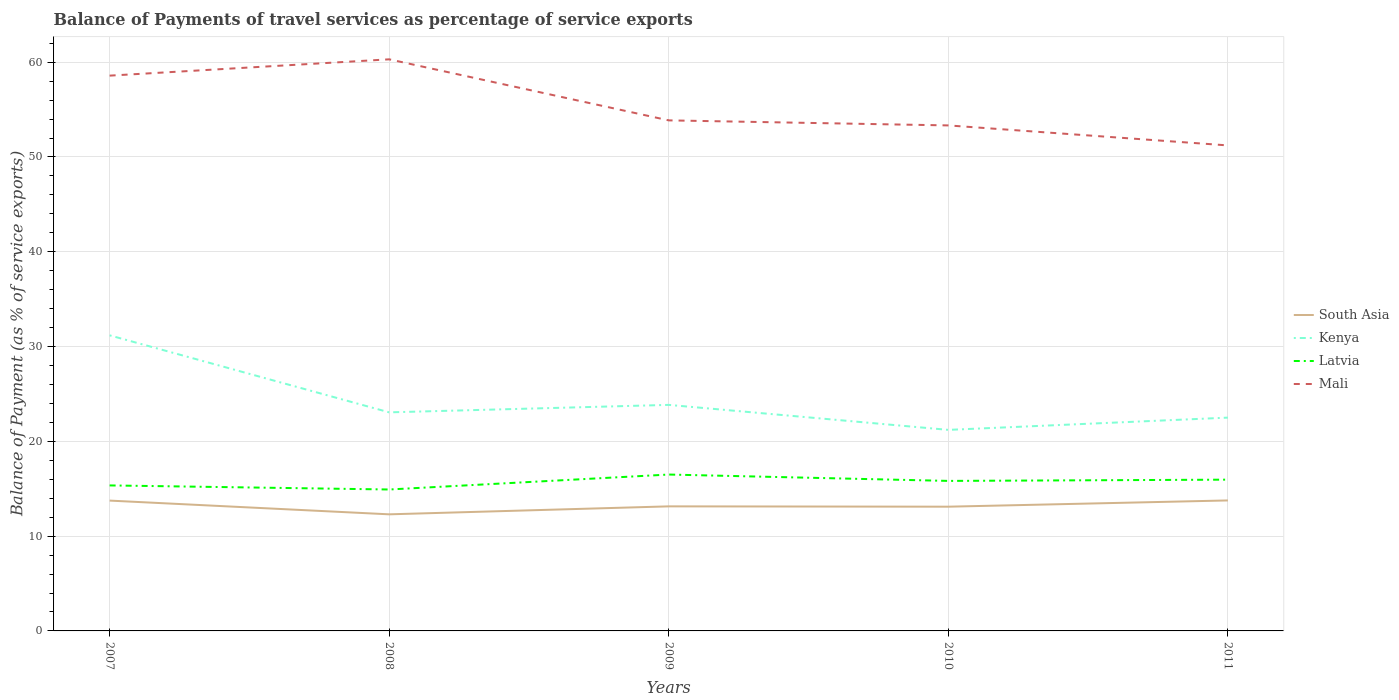Is the number of lines equal to the number of legend labels?
Give a very brief answer. Yes. Across all years, what is the maximum balance of payments of travel services in South Asia?
Give a very brief answer. 12.3. In which year was the balance of payments of travel services in South Asia maximum?
Offer a terse response. 2008. What is the total balance of payments of travel services in Mali in the graph?
Ensure brevity in your answer.  6.97. What is the difference between the highest and the second highest balance of payments of travel services in Kenya?
Ensure brevity in your answer.  9.97. Does the graph contain any zero values?
Your answer should be compact. No. Does the graph contain grids?
Provide a short and direct response. Yes. How are the legend labels stacked?
Offer a terse response. Vertical. What is the title of the graph?
Make the answer very short. Balance of Payments of travel services as percentage of service exports. What is the label or title of the X-axis?
Your response must be concise. Years. What is the label or title of the Y-axis?
Provide a short and direct response. Balance of Payment (as % of service exports). What is the Balance of Payment (as % of service exports) of South Asia in 2007?
Offer a very short reply. 13.75. What is the Balance of Payment (as % of service exports) of Kenya in 2007?
Keep it short and to the point. 31.18. What is the Balance of Payment (as % of service exports) in Latvia in 2007?
Offer a terse response. 15.35. What is the Balance of Payment (as % of service exports) of Mali in 2007?
Offer a very short reply. 58.58. What is the Balance of Payment (as % of service exports) of South Asia in 2008?
Offer a very short reply. 12.3. What is the Balance of Payment (as % of service exports) in Kenya in 2008?
Give a very brief answer. 23.06. What is the Balance of Payment (as % of service exports) in Latvia in 2008?
Keep it short and to the point. 14.92. What is the Balance of Payment (as % of service exports) of Mali in 2008?
Provide a short and direct response. 60.3. What is the Balance of Payment (as % of service exports) of South Asia in 2009?
Offer a very short reply. 13.14. What is the Balance of Payment (as % of service exports) of Kenya in 2009?
Ensure brevity in your answer.  23.85. What is the Balance of Payment (as % of service exports) in Latvia in 2009?
Provide a succinct answer. 16.5. What is the Balance of Payment (as % of service exports) of Mali in 2009?
Provide a short and direct response. 53.86. What is the Balance of Payment (as % of service exports) in South Asia in 2010?
Make the answer very short. 13.11. What is the Balance of Payment (as % of service exports) of Kenya in 2010?
Keep it short and to the point. 21.21. What is the Balance of Payment (as % of service exports) in Latvia in 2010?
Keep it short and to the point. 15.83. What is the Balance of Payment (as % of service exports) in Mali in 2010?
Your answer should be compact. 53.33. What is the Balance of Payment (as % of service exports) of South Asia in 2011?
Offer a terse response. 13.77. What is the Balance of Payment (as % of service exports) in Kenya in 2011?
Your answer should be compact. 22.5. What is the Balance of Payment (as % of service exports) of Latvia in 2011?
Provide a succinct answer. 15.96. What is the Balance of Payment (as % of service exports) in Mali in 2011?
Ensure brevity in your answer.  51.22. Across all years, what is the maximum Balance of Payment (as % of service exports) in South Asia?
Give a very brief answer. 13.77. Across all years, what is the maximum Balance of Payment (as % of service exports) of Kenya?
Give a very brief answer. 31.18. Across all years, what is the maximum Balance of Payment (as % of service exports) of Latvia?
Provide a short and direct response. 16.5. Across all years, what is the maximum Balance of Payment (as % of service exports) of Mali?
Provide a short and direct response. 60.3. Across all years, what is the minimum Balance of Payment (as % of service exports) of South Asia?
Make the answer very short. 12.3. Across all years, what is the minimum Balance of Payment (as % of service exports) of Kenya?
Ensure brevity in your answer.  21.21. Across all years, what is the minimum Balance of Payment (as % of service exports) in Latvia?
Your answer should be very brief. 14.92. Across all years, what is the minimum Balance of Payment (as % of service exports) in Mali?
Offer a terse response. 51.22. What is the total Balance of Payment (as % of service exports) in South Asia in the graph?
Your response must be concise. 66.07. What is the total Balance of Payment (as % of service exports) of Kenya in the graph?
Make the answer very short. 121.8. What is the total Balance of Payment (as % of service exports) of Latvia in the graph?
Make the answer very short. 78.55. What is the total Balance of Payment (as % of service exports) in Mali in the graph?
Keep it short and to the point. 277.3. What is the difference between the Balance of Payment (as % of service exports) of South Asia in 2007 and that in 2008?
Your answer should be very brief. 1.45. What is the difference between the Balance of Payment (as % of service exports) in Kenya in 2007 and that in 2008?
Your answer should be very brief. 8.12. What is the difference between the Balance of Payment (as % of service exports) in Latvia in 2007 and that in 2008?
Give a very brief answer. 0.43. What is the difference between the Balance of Payment (as % of service exports) of Mali in 2007 and that in 2008?
Provide a succinct answer. -1.72. What is the difference between the Balance of Payment (as % of service exports) in South Asia in 2007 and that in 2009?
Offer a very short reply. 0.61. What is the difference between the Balance of Payment (as % of service exports) in Kenya in 2007 and that in 2009?
Your answer should be compact. 7.34. What is the difference between the Balance of Payment (as % of service exports) in Latvia in 2007 and that in 2009?
Provide a short and direct response. -1.15. What is the difference between the Balance of Payment (as % of service exports) in Mali in 2007 and that in 2009?
Offer a very short reply. 4.72. What is the difference between the Balance of Payment (as % of service exports) in South Asia in 2007 and that in 2010?
Make the answer very short. 0.64. What is the difference between the Balance of Payment (as % of service exports) of Kenya in 2007 and that in 2010?
Your response must be concise. 9.97. What is the difference between the Balance of Payment (as % of service exports) of Latvia in 2007 and that in 2010?
Your answer should be compact. -0.48. What is the difference between the Balance of Payment (as % of service exports) of Mali in 2007 and that in 2010?
Your answer should be very brief. 5.25. What is the difference between the Balance of Payment (as % of service exports) of South Asia in 2007 and that in 2011?
Ensure brevity in your answer.  -0.02. What is the difference between the Balance of Payment (as % of service exports) of Kenya in 2007 and that in 2011?
Your response must be concise. 8.68. What is the difference between the Balance of Payment (as % of service exports) of Latvia in 2007 and that in 2011?
Your answer should be very brief. -0.61. What is the difference between the Balance of Payment (as % of service exports) of Mali in 2007 and that in 2011?
Your response must be concise. 7.36. What is the difference between the Balance of Payment (as % of service exports) of South Asia in 2008 and that in 2009?
Offer a very short reply. -0.84. What is the difference between the Balance of Payment (as % of service exports) in Kenya in 2008 and that in 2009?
Ensure brevity in your answer.  -0.79. What is the difference between the Balance of Payment (as % of service exports) of Latvia in 2008 and that in 2009?
Ensure brevity in your answer.  -1.58. What is the difference between the Balance of Payment (as % of service exports) of Mali in 2008 and that in 2009?
Make the answer very short. 6.44. What is the difference between the Balance of Payment (as % of service exports) of South Asia in 2008 and that in 2010?
Make the answer very short. -0.81. What is the difference between the Balance of Payment (as % of service exports) in Kenya in 2008 and that in 2010?
Provide a succinct answer. 1.85. What is the difference between the Balance of Payment (as % of service exports) in Latvia in 2008 and that in 2010?
Keep it short and to the point. -0.91. What is the difference between the Balance of Payment (as % of service exports) of Mali in 2008 and that in 2010?
Your response must be concise. 6.97. What is the difference between the Balance of Payment (as % of service exports) in South Asia in 2008 and that in 2011?
Provide a succinct answer. -1.47. What is the difference between the Balance of Payment (as % of service exports) of Kenya in 2008 and that in 2011?
Keep it short and to the point. 0.56. What is the difference between the Balance of Payment (as % of service exports) of Latvia in 2008 and that in 2011?
Your response must be concise. -1.04. What is the difference between the Balance of Payment (as % of service exports) of Mali in 2008 and that in 2011?
Offer a very short reply. 9.08. What is the difference between the Balance of Payment (as % of service exports) in South Asia in 2009 and that in 2010?
Give a very brief answer. 0.04. What is the difference between the Balance of Payment (as % of service exports) in Kenya in 2009 and that in 2010?
Give a very brief answer. 2.64. What is the difference between the Balance of Payment (as % of service exports) of Latvia in 2009 and that in 2010?
Your answer should be very brief. 0.67. What is the difference between the Balance of Payment (as % of service exports) in Mali in 2009 and that in 2010?
Your response must be concise. 0.53. What is the difference between the Balance of Payment (as % of service exports) in South Asia in 2009 and that in 2011?
Your answer should be compact. -0.62. What is the difference between the Balance of Payment (as % of service exports) in Kenya in 2009 and that in 2011?
Provide a short and direct response. 1.34. What is the difference between the Balance of Payment (as % of service exports) in Latvia in 2009 and that in 2011?
Provide a short and direct response. 0.54. What is the difference between the Balance of Payment (as % of service exports) in Mali in 2009 and that in 2011?
Keep it short and to the point. 2.64. What is the difference between the Balance of Payment (as % of service exports) of South Asia in 2010 and that in 2011?
Your response must be concise. -0.66. What is the difference between the Balance of Payment (as % of service exports) in Kenya in 2010 and that in 2011?
Provide a short and direct response. -1.29. What is the difference between the Balance of Payment (as % of service exports) of Latvia in 2010 and that in 2011?
Offer a very short reply. -0.13. What is the difference between the Balance of Payment (as % of service exports) in Mali in 2010 and that in 2011?
Provide a short and direct response. 2.11. What is the difference between the Balance of Payment (as % of service exports) in South Asia in 2007 and the Balance of Payment (as % of service exports) in Kenya in 2008?
Give a very brief answer. -9.31. What is the difference between the Balance of Payment (as % of service exports) of South Asia in 2007 and the Balance of Payment (as % of service exports) of Latvia in 2008?
Your answer should be compact. -1.17. What is the difference between the Balance of Payment (as % of service exports) of South Asia in 2007 and the Balance of Payment (as % of service exports) of Mali in 2008?
Provide a succinct answer. -46.55. What is the difference between the Balance of Payment (as % of service exports) of Kenya in 2007 and the Balance of Payment (as % of service exports) of Latvia in 2008?
Offer a very short reply. 16.26. What is the difference between the Balance of Payment (as % of service exports) in Kenya in 2007 and the Balance of Payment (as % of service exports) in Mali in 2008?
Provide a short and direct response. -29.12. What is the difference between the Balance of Payment (as % of service exports) in Latvia in 2007 and the Balance of Payment (as % of service exports) in Mali in 2008?
Your response must be concise. -44.95. What is the difference between the Balance of Payment (as % of service exports) in South Asia in 2007 and the Balance of Payment (as % of service exports) in Kenya in 2009?
Your response must be concise. -10.1. What is the difference between the Balance of Payment (as % of service exports) in South Asia in 2007 and the Balance of Payment (as % of service exports) in Latvia in 2009?
Provide a succinct answer. -2.75. What is the difference between the Balance of Payment (as % of service exports) of South Asia in 2007 and the Balance of Payment (as % of service exports) of Mali in 2009?
Offer a terse response. -40.11. What is the difference between the Balance of Payment (as % of service exports) in Kenya in 2007 and the Balance of Payment (as % of service exports) in Latvia in 2009?
Give a very brief answer. 14.69. What is the difference between the Balance of Payment (as % of service exports) of Kenya in 2007 and the Balance of Payment (as % of service exports) of Mali in 2009?
Provide a succinct answer. -22.68. What is the difference between the Balance of Payment (as % of service exports) in Latvia in 2007 and the Balance of Payment (as % of service exports) in Mali in 2009?
Give a very brief answer. -38.51. What is the difference between the Balance of Payment (as % of service exports) in South Asia in 2007 and the Balance of Payment (as % of service exports) in Kenya in 2010?
Your answer should be very brief. -7.46. What is the difference between the Balance of Payment (as % of service exports) of South Asia in 2007 and the Balance of Payment (as % of service exports) of Latvia in 2010?
Ensure brevity in your answer.  -2.08. What is the difference between the Balance of Payment (as % of service exports) of South Asia in 2007 and the Balance of Payment (as % of service exports) of Mali in 2010?
Give a very brief answer. -39.58. What is the difference between the Balance of Payment (as % of service exports) of Kenya in 2007 and the Balance of Payment (as % of service exports) of Latvia in 2010?
Your answer should be very brief. 15.36. What is the difference between the Balance of Payment (as % of service exports) in Kenya in 2007 and the Balance of Payment (as % of service exports) in Mali in 2010?
Keep it short and to the point. -22.15. What is the difference between the Balance of Payment (as % of service exports) of Latvia in 2007 and the Balance of Payment (as % of service exports) of Mali in 2010?
Give a very brief answer. -37.98. What is the difference between the Balance of Payment (as % of service exports) of South Asia in 2007 and the Balance of Payment (as % of service exports) of Kenya in 2011?
Make the answer very short. -8.75. What is the difference between the Balance of Payment (as % of service exports) in South Asia in 2007 and the Balance of Payment (as % of service exports) in Latvia in 2011?
Offer a terse response. -2.21. What is the difference between the Balance of Payment (as % of service exports) of South Asia in 2007 and the Balance of Payment (as % of service exports) of Mali in 2011?
Give a very brief answer. -37.47. What is the difference between the Balance of Payment (as % of service exports) of Kenya in 2007 and the Balance of Payment (as % of service exports) of Latvia in 2011?
Make the answer very short. 15.23. What is the difference between the Balance of Payment (as % of service exports) of Kenya in 2007 and the Balance of Payment (as % of service exports) of Mali in 2011?
Offer a very short reply. -20.04. What is the difference between the Balance of Payment (as % of service exports) of Latvia in 2007 and the Balance of Payment (as % of service exports) of Mali in 2011?
Your response must be concise. -35.87. What is the difference between the Balance of Payment (as % of service exports) in South Asia in 2008 and the Balance of Payment (as % of service exports) in Kenya in 2009?
Provide a short and direct response. -11.55. What is the difference between the Balance of Payment (as % of service exports) of South Asia in 2008 and the Balance of Payment (as % of service exports) of Latvia in 2009?
Provide a succinct answer. -4.2. What is the difference between the Balance of Payment (as % of service exports) in South Asia in 2008 and the Balance of Payment (as % of service exports) in Mali in 2009?
Keep it short and to the point. -41.56. What is the difference between the Balance of Payment (as % of service exports) in Kenya in 2008 and the Balance of Payment (as % of service exports) in Latvia in 2009?
Offer a very short reply. 6.56. What is the difference between the Balance of Payment (as % of service exports) in Kenya in 2008 and the Balance of Payment (as % of service exports) in Mali in 2009?
Provide a succinct answer. -30.8. What is the difference between the Balance of Payment (as % of service exports) in Latvia in 2008 and the Balance of Payment (as % of service exports) in Mali in 2009?
Your answer should be very brief. -38.94. What is the difference between the Balance of Payment (as % of service exports) of South Asia in 2008 and the Balance of Payment (as % of service exports) of Kenya in 2010?
Your response must be concise. -8.91. What is the difference between the Balance of Payment (as % of service exports) in South Asia in 2008 and the Balance of Payment (as % of service exports) in Latvia in 2010?
Your answer should be very brief. -3.53. What is the difference between the Balance of Payment (as % of service exports) in South Asia in 2008 and the Balance of Payment (as % of service exports) in Mali in 2010?
Give a very brief answer. -41.03. What is the difference between the Balance of Payment (as % of service exports) of Kenya in 2008 and the Balance of Payment (as % of service exports) of Latvia in 2010?
Your answer should be compact. 7.23. What is the difference between the Balance of Payment (as % of service exports) in Kenya in 2008 and the Balance of Payment (as % of service exports) in Mali in 2010?
Keep it short and to the point. -30.27. What is the difference between the Balance of Payment (as % of service exports) of Latvia in 2008 and the Balance of Payment (as % of service exports) of Mali in 2010?
Ensure brevity in your answer.  -38.41. What is the difference between the Balance of Payment (as % of service exports) in South Asia in 2008 and the Balance of Payment (as % of service exports) in Kenya in 2011?
Keep it short and to the point. -10.2. What is the difference between the Balance of Payment (as % of service exports) of South Asia in 2008 and the Balance of Payment (as % of service exports) of Latvia in 2011?
Provide a short and direct response. -3.66. What is the difference between the Balance of Payment (as % of service exports) of South Asia in 2008 and the Balance of Payment (as % of service exports) of Mali in 2011?
Offer a terse response. -38.92. What is the difference between the Balance of Payment (as % of service exports) in Kenya in 2008 and the Balance of Payment (as % of service exports) in Latvia in 2011?
Make the answer very short. 7.1. What is the difference between the Balance of Payment (as % of service exports) in Kenya in 2008 and the Balance of Payment (as % of service exports) in Mali in 2011?
Offer a very short reply. -28.16. What is the difference between the Balance of Payment (as % of service exports) in Latvia in 2008 and the Balance of Payment (as % of service exports) in Mali in 2011?
Provide a short and direct response. -36.3. What is the difference between the Balance of Payment (as % of service exports) of South Asia in 2009 and the Balance of Payment (as % of service exports) of Kenya in 2010?
Ensure brevity in your answer.  -8.07. What is the difference between the Balance of Payment (as % of service exports) in South Asia in 2009 and the Balance of Payment (as % of service exports) in Latvia in 2010?
Provide a succinct answer. -2.68. What is the difference between the Balance of Payment (as % of service exports) in South Asia in 2009 and the Balance of Payment (as % of service exports) in Mali in 2010?
Give a very brief answer. -40.19. What is the difference between the Balance of Payment (as % of service exports) of Kenya in 2009 and the Balance of Payment (as % of service exports) of Latvia in 2010?
Give a very brief answer. 8.02. What is the difference between the Balance of Payment (as % of service exports) of Kenya in 2009 and the Balance of Payment (as % of service exports) of Mali in 2010?
Give a very brief answer. -29.48. What is the difference between the Balance of Payment (as % of service exports) of Latvia in 2009 and the Balance of Payment (as % of service exports) of Mali in 2010?
Your response must be concise. -36.83. What is the difference between the Balance of Payment (as % of service exports) in South Asia in 2009 and the Balance of Payment (as % of service exports) in Kenya in 2011?
Your response must be concise. -9.36. What is the difference between the Balance of Payment (as % of service exports) in South Asia in 2009 and the Balance of Payment (as % of service exports) in Latvia in 2011?
Your response must be concise. -2.82. What is the difference between the Balance of Payment (as % of service exports) in South Asia in 2009 and the Balance of Payment (as % of service exports) in Mali in 2011?
Your response must be concise. -38.08. What is the difference between the Balance of Payment (as % of service exports) in Kenya in 2009 and the Balance of Payment (as % of service exports) in Latvia in 2011?
Your answer should be compact. 7.89. What is the difference between the Balance of Payment (as % of service exports) of Kenya in 2009 and the Balance of Payment (as % of service exports) of Mali in 2011?
Give a very brief answer. -27.37. What is the difference between the Balance of Payment (as % of service exports) of Latvia in 2009 and the Balance of Payment (as % of service exports) of Mali in 2011?
Provide a short and direct response. -34.72. What is the difference between the Balance of Payment (as % of service exports) in South Asia in 2010 and the Balance of Payment (as % of service exports) in Kenya in 2011?
Offer a very short reply. -9.4. What is the difference between the Balance of Payment (as % of service exports) of South Asia in 2010 and the Balance of Payment (as % of service exports) of Latvia in 2011?
Provide a succinct answer. -2.85. What is the difference between the Balance of Payment (as % of service exports) of South Asia in 2010 and the Balance of Payment (as % of service exports) of Mali in 2011?
Your answer should be very brief. -38.12. What is the difference between the Balance of Payment (as % of service exports) of Kenya in 2010 and the Balance of Payment (as % of service exports) of Latvia in 2011?
Offer a terse response. 5.25. What is the difference between the Balance of Payment (as % of service exports) in Kenya in 2010 and the Balance of Payment (as % of service exports) in Mali in 2011?
Your answer should be very brief. -30.01. What is the difference between the Balance of Payment (as % of service exports) in Latvia in 2010 and the Balance of Payment (as % of service exports) in Mali in 2011?
Provide a succinct answer. -35.39. What is the average Balance of Payment (as % of service exports) in South Asia per year?
Ensure brevity in your answer.  13.21. What is the average Balance of Payment (as % of service exports) in Kenya per year?
Ensure brevity in your answer.  24.36. What is the average Balance of Payment (as % of service exports) in Latvia per year?
Your answer should be compact. 15.71. What is the average Balance of Payment (as % of service exports) in Mali per year?
Keep it short and to the point. 55.46. In the year 2007, what is the difference between the Balance of Payment (as % of service exports) of South Asia and Balance of Payment (as % of service exports) of Kenya?
Ensure brevity in your answer.  -17.43. In the year 2007, what is the difference between the Balance of Payment (as % of service exports) of South Asia and Balance of Payment (as % of service exports) of Latvia?
Provide a short and direct response. -1.6. In the year 2007, what is the difference between the Balance of Payment (as % of service exports) in South Asia and Balance of Payment (as % of service exports) in Mali?
Offer a very short reply. -44.83. In the year 2007, what is the difference between the Balance of Payment (as % of service exports) in Kenya and Balance of Payment (as % of service exports) in Latvia?
Provide a succinct answer. 15.83. In the year 2007, what is the difference between the Balance of Payment (as % of service exports) of Kenya and Balance of Payment (as % of service exports) of Mali?
Give a very brief answer. -27.4. In the year 2007, what is the difference between the Balance of Payment (as % of service exports) in Latvia and Balance of Payment (as % of service exports) in Mali?
Ensure brevity in your answer.  -43.23. In the year 2008, what is the difference between the Balance of Payment (as % of service exports) of South Asia and Balance of Payment (as % of service exports) of Kenya?
Make the answer very short. -10.76. In the year 2008, what is the difference between the Balance of Payment (as % of service exports) of South Asia and Balance of Payment (as % of service exports) of Latvia?
Your answer should be compact. -2.62. In the year 2008, what is the difference between the Balance of Payment (as % of service exports) in South Asia and Balance of Payment (as % of service exports) in Mali?
Make the answer very short. -48. In the year 2008, what is the difference between the Balance of Payment (as % of service exports) in Kenya and Balance of Payment (as % of service exports) in Latvia?
Offer a very short reply. 8.14. In the year 2008, what is the difference between the Balance of Payment (as % of service exports) of Kenya and Balance of Payment (as % of service exports) of Mali?
Ensure brevity in your answer.  -37.24. In the year 2008, what is the difference between the Balance of Payment (as % of service exports) in Latvia and Balance of Payment (as % of service exports) in Mali?
Your answer should be very brief. -45.38. In the year 2009, what is the difference between the Balance of Payment (as % of service exports) in South Asia and Balance of Payment (as % of service exports) in Kenya?
Offer a very short reply. -10.71. In the year 2009, what is the difference between the Balance of Payment (as % of service exports) in South Asia and Balance of Payment (as % of service exports) in Latvia?
Offer a terse response. -3.36. In the year 2009, what is the difference between the Balance of Payment (as % of service exports) of South Asia and Balance of Payment (as % of service exports) of Mali?
Provide a succinct answer. -40.72. In the year 2009, what is the difference between the Balance of Payment (as % of service exports) of Kenya and Balance of Payment (as % of service exports) of Latvia?
Offer a very short reply. 7.35. In the year 2009, what is the difference between the Balance of Payment (as % of service exports) in Kenya and Balance of Payment (as % of service exports) in Mali?
Offer a terse response. -30.02. In the year 2009, what is the difference between the Balance of Payment (as % of service exports) in Latvia and Balance of Payment (as % of service exports) in Mali?
Give a very brief answer. -37.36. In the year 2010, what is the difference between the Balance of Payment (as % of service exports) of South Asia and Balance of Payment (as % of service exports) of Kenya?
Keep it short and to the point. -8.1. In the year 2010, what is the difference between the Balance of Payment (as % of service exports) in South Asia and Balance of Payment (as % of service exports) in Latvia?
Provide a short and direct response. -2.72. In the year 2010, what is the difference between the Balance of Payment (as % of service exports) in South Asia and Balance of Payment (as % of service exports) in Mali?
Your response must be concise. -40.22. In the year 2010, what is the difference between the Balance of Payment (as % of service exports) of Kenya and Balance of Payment (as % of service exports) of Latvia?
Your answer should be compact. 5.38. In the year 2010, what is the difference between the Balance of Payment (as % of service exports) in Kenya and Balance of Payment (as % of service exports) in Mali?
Ensure brevity in your answer.  -32.12. In the year 2010, what is the difference between the Balance of Payment (as % of service exports) of Latvia and Balance of Payment (as % of service exports) of Mali?
Give a very brief answer. -37.5. In the year 2011, what is the difference between the Balance of Payment (as % of service exports) of South Asia and Balance of Payment (as % of service exports) of Kenya?
Give a very brief answer. -8.74. In the year 2011, what is the difference between the Balance of Payment (as % of service exports) in South Asia and Balance of Payment (as % of service exports) in Latvia?
Your answer should be very brief. -2.19. In the year 2011, what is the difference between the Balance of Payment (as % of service exports) of South Asia and Balance of Payment (as % of service exports) of Mali?
Your answer should be compact. -37.45. In the year 2011, what is the difference between the Balance of Payment (as % of service exports) in Kenya and Balance of Payment (as % of service exports) in Latvia?
Offer a terse response. 6.54. In the year 2011, what is the difference between the Balance of Payment (as % of service exports) of Kenya and Balance of Payment (as % of service exports) of Mali?
Your answer should be compact. -28.72. In the year 2011, what is the difference between the Balance of Payment (as % of service exports) of Latvia and Balance of Payment (as % of service exports) of Mali?
Offer a terse response. -35.26. What is the ratio of the Balance of Payment (as % of service exports) of South Asia in 2007 to that in 2008?
Your response must be concise. 1.12. What is the ratio of the Balance of Payment (as % of service exports) in Kenya in 2007 to that in 2008?
Offer a terse response. 1.35. What is the ratio of the Balance of Payment (as % of service exports) of Latvia in 2007 to that in 2008?
Your answer should be very brief. 1.03. What is the ratio of the Balance of Payment (as % of service exports) in Mali in 2007 to that in 2008?
Your answer should be very brief. 0.97. What is the ratio of the Balance of Payment (as % of service exports) of South Asia in 2007 to that in 2009?
Offer a terse response. 1.05. What is the ratio of the Balance of Payment (as % of service exports) of Kenya in 2007 to that in 2009?
Offer a very short reply. 1.31. What is the ratio of the Balance of Payment (as % of service exports) in Latvia in 2007 to that in 2009?
Offer a very short reply. 0.93. What is the ratio of the Balance of Payment (as % of service exports) in Mali in 2007 to that in 2009?
Your response must be concise. 1.09. What is the ratio of the Balance of Payment (as % of service exports) in South Asia in 2007 to that in 2010?
Provide a short and direct response. 1.05. What is the ratio of the Balance of Payment (as % of service exports) in Kenya in 2007 to that in 2010?
Provide a short and direct response. 1.47. What is the ratio of the Balance of Payment (as % of service exports) in Latvia in 2007 to that in 2010?
Offer a terse response. 0.97. What is the ratio of the Balance of Payment (as % of service exports) in Mali in 2007 to that in 2010?
Offer a very short reply. 1.1. What is the ratio of the Balance of Payment (as % of service exports) of Kenya in 2007 to that in 2011?
Provide a short and direct response. 1.39. What is the ratio of the Balance of Payment (as % of service exports) in Latvia in 2007 to that in 2011?
Provide a short and direct response. 0.96. What is the ratio of the Balance of Payment (as % of service exports) in Mali in 2007 to that in 2011?
Offer a very short reply. 1.14. What is the ratio of the Balance of Payment (as % of service exports) in South Asia in 2008 to that in 2009?
Make the answer very short. 0.94. What is the ratio of the Balance of Payment (as % of service exports) of Latvia in 2008 to that in 2009?
Give a very brief answer. 0.9. What is the ratio of the Balance of Payment (as % of service exports) in Mali in 2008 to that in 2009?
Your response must be concise. 1.12. What is the ratio of the Balance of Payment (as % of service exports) of South Asia in 2008 to that in 2010?
Offer a terse response. 0.94. What is the ratio of the Balance of Payment (as % of service exports) of Kenya in 2008 to that in 2010?
Your answer should be very brief. 1.09. What is the ratio of the Balance of Payment (as % of service exports) of Latvia in 2008 to that in 2010?
Your answer should be compact. 0.94. What is the ratio of the Balance of Payment (as % of service exports) of Mali in 2008 to that in 2010?
Provide a short and direct response. 1.13. What is the ratio of the Balance of Payment (as % of service exports) in South Asia in 2008 to that in 2011?
Provide a short and direct response. 0.89. What is the ratio of the Balance of Payment (as % of service exports) of Kenya in 2008 to that in 2011?
Your answer should be very brief. 1.02. What is the ratio of the Balance of Payment (as % of service exports) of Latvia in 2008 to that in 2011?
Keep it short and to the point. 0.93. What is the ratio of the Balance of Payment (as % of service exports) in Mali in 2008 to that in 2011?
Provide a short and direct response. 1.18. What is the ratio of the Balance of Payment (as % of service exports) of South Asia in 2009 to that in 2010?
Provide a succinct answer. 1. What is the ratio of the Balance of Payment (as % of service exports) of Kenya in 2009 to that in 2010?
Ensure brevity in your answer.  1.12. What is the ratio of the Balance of Payment (as % of service exports) of Latvia in 2009 to that in 2010?
Offer a terse response. 1.04. What is the ratio of the Balance of Payment (as % of service exports) in South Asia in 2009 to that in 2011?
Ensure brevity in your answer.  0.95. What is the ratio of the Balance of Payment (as % of service exports) of Kenya in 2009 to that in 2011?
Your response must be concise. 1.06. What is the ratio of the Balance of Payment (as % of service exports) of Latvia in 2009 to that in 2011?
Your response must be concise. 1.03. What is the ratio of the Balance of Payment (as % of service exports) in Mali in 2009 to that in 2011?
Offer a terse response. 1.05. What is the ratio of the Balance of Payment (as % of service exports) of Kenya in 2010 to that in 2011?
Offer a terse response. 0.94. What is the ratio of the Balance of Payment (as % of service exports) of Mali in 2010 to that in 2011?
Provide a succinct answer. 1.04. What is the difference between the highest and the second highest Balance of Payment (as % of service exports) of South Asia?
Your response must be concise. 0.02. What is the difference between the highest and the second highest Balance of Payment (as % of service exports) in Kenya?
Keep it short and to the point. 7.34. What is the difference between the highest and the second highest Balance of Payment (as % of service exports) in Latvia?
Provide a succinct answer. 0.54. What is the difference between the highest and the second highest Balance of Payment (as % of service exports) in Mali?
Your answer should be compact. 1.72. What is the difference between the highest and the lowest Balance of Payment (as % of service exports) in South Asia?
Your response must be concise. 1.47. What is the difference between the highest and the lowest Balance of Payment (as % of service exports) of Kenya?
Your answer should be very brief. 9.97. What is the difference between the highest and the lowest Balance of Payment (as % of service exports) of Latvia?
Your response must be concise. 1.58. What is the difference between the highest and the lowest Balance of Payment (as % of service exports) of Mali?
Keep it short and to the point. 9.08. 